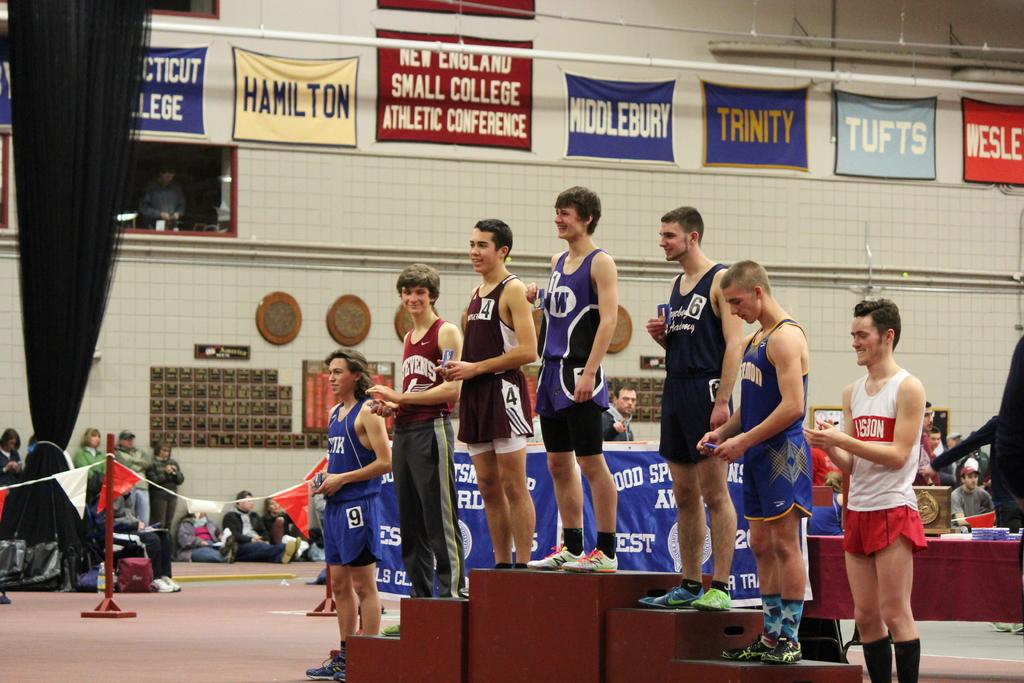Provide a one-sentence caption for the provided image. Boys standing on a pedestal for a small college conference from a variety of schools including Hamilton, Middlebury, Trinity, and Tufts. 